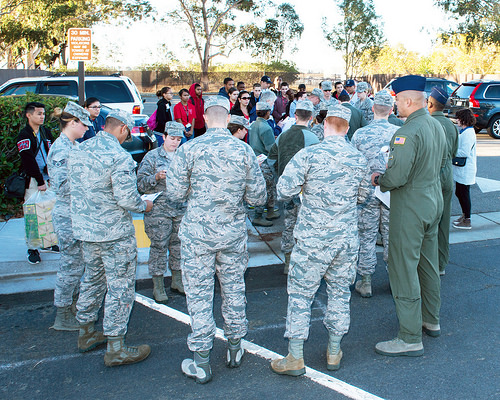<image>
Is there a soldier next to the soldier? Yes. The soldier is positioned adjacent to the soldier, located nearby in the same general area. Where is the vehicle in relation to the man? Is it in front of the man? No. The vehicle is not in front of the man. The spatial positioning shows a different relationship between these objects. 